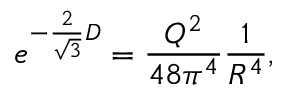Convert formula to latex. <formula><loc_0><loc_0><loc_500><loc_500>e ^ { - { \frac { 2 } { \sqrt { 3 } } } D } = { \frac { Q ^ { 2 } } { 4 8 \pi ^ { 4 } } } { \frac { 1 } { R ^ { 4 } } } ,</formula> 